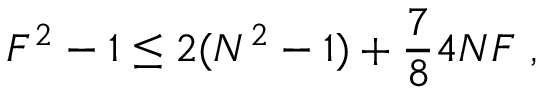Convert formula to latex. <formula><loc_0><loc_0><loc_500><loc_500>F ^ { 2 } - 1 \leq 2 ( N ^ { 2 } - 1 ) + \frac { 7 } { 8 } 4 N F \ ,</formula> 